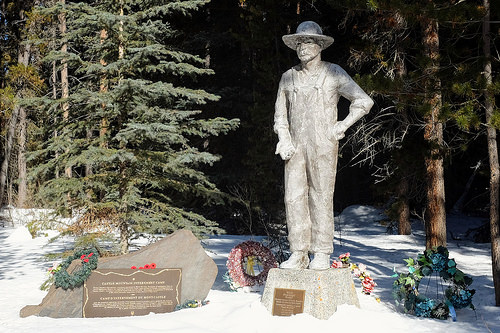<image>
Is the stone to the left of the statue? Yes. From this viewpoint, the stone is positioned to the left side relative to the statue. 